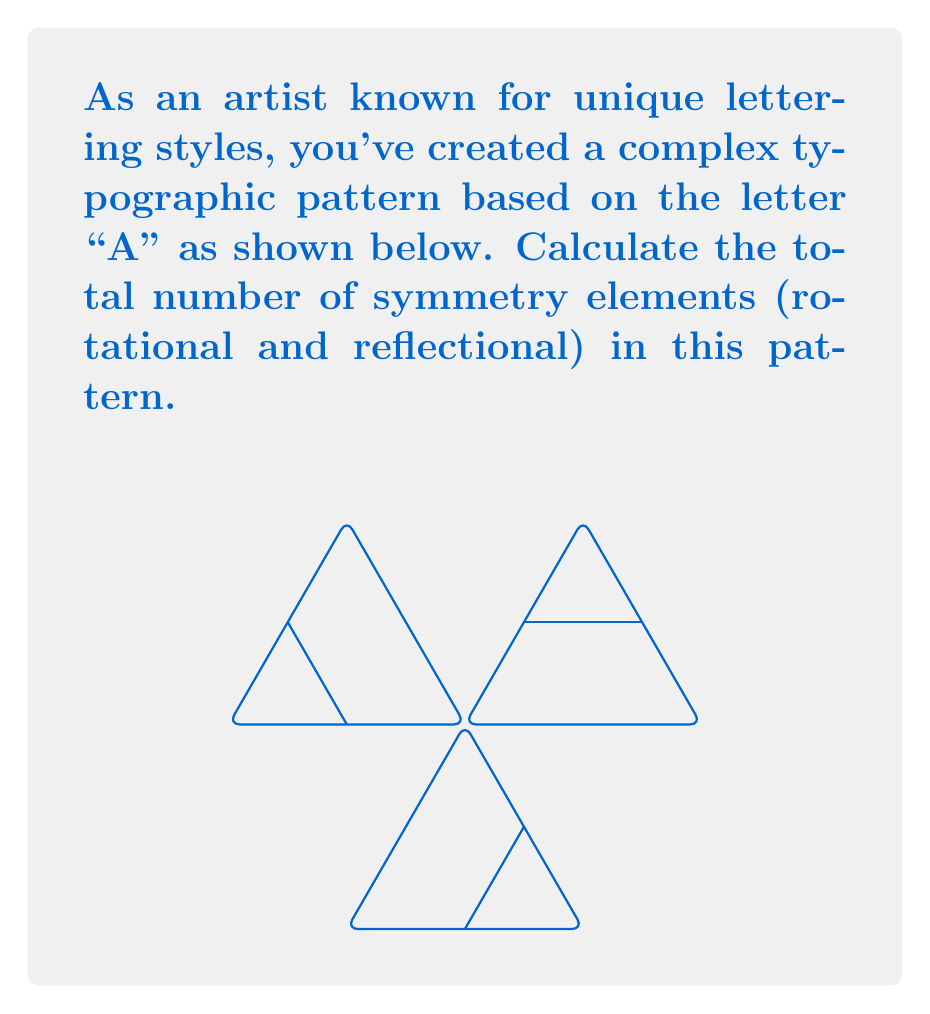Teach me how to tackle this problem. To find the symmetry elements of this typographic pattern, we need to analyze both rotational and reflectional symmetries:

1. Rotational symmetry:
   - The pattern has 3-fold rotational symmetry (120° rotations).
   - There are 3 distinct rotations: 0°, 120°, and 240°.

2. Reflectional symmetry:
   - The pattern has 3 lines of reflection, each passing through a vertex and the midpoint of the opposite side of the triangle.

To calculate the total number of symmetry elements:

$$\text{Total symmetry elements} = \text{Rotational symmetries} + \text{Reflectional symmetries}$$
$$\text{Total symmetry elements} = 3 + 3 = 6$$

Therefore, the complex typographic pattern based on the letter "A" has 6 symmetry elements in total.
Answer: 6 